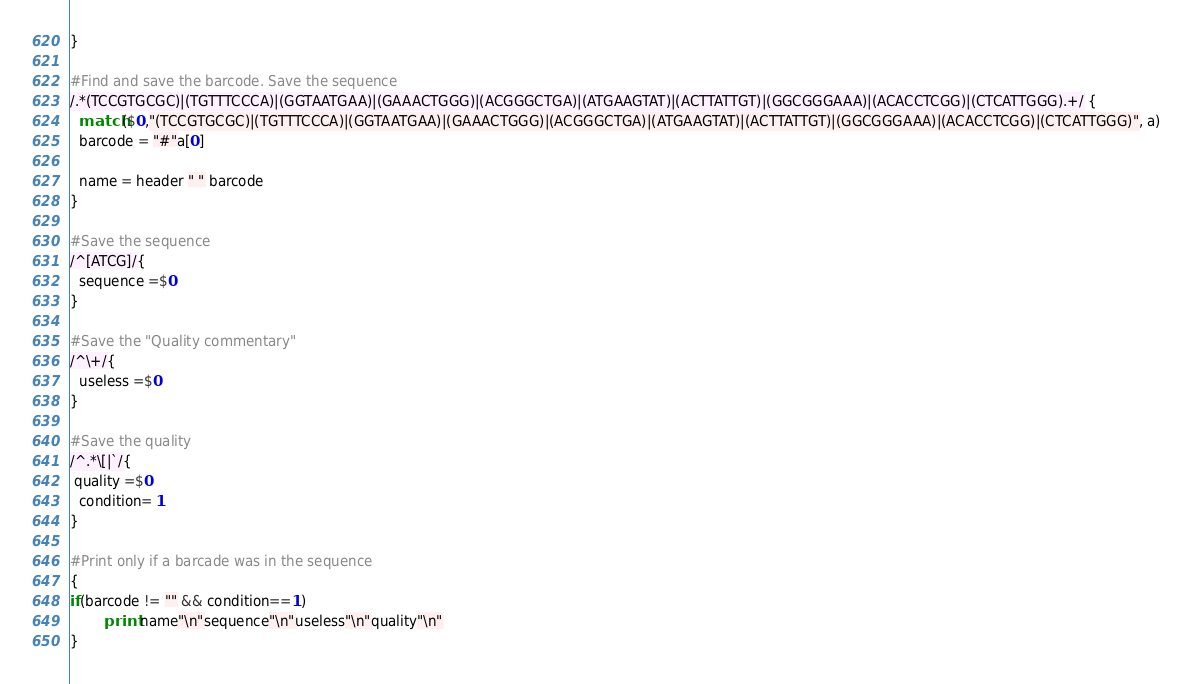<code> <loc_0><loc_0><loc_500><loc_500><_Awk_>}

#Find and save the barcode. Save the sequence
/.*(TCCGTGCGC)|(TGTTTCCCA)|(GGTAATGAA)|(GAAACTGGG)|(ACGGGCTGA)|(ATGAAGTAT)|(ACTTATTGT)|(GGCGGGAAA)|(ACACCTCGG)|(CTCATTGGG).+/ {
  match($0,"(TCCGTGCGC)|(TGTTTCCCA)|(GGTAATGAA)|(GAAACTGGG)|(ACGGGCTGA)|(ATGAAGTAT)|(ACTTATTGT)|(GGCGGGAAA)|(ACACCTCGG)|(CTCATTGGG)", a)
  barcode = "#"a[0]

  name = header " " barcode
}

#Save the sequence
/^[ATCG]/{
  sequence =$0
}

#Save the "Quality commentary"
/^\+/{
  useless =$0
}

#Save the quality
/^.*\[|`/{
 quality =$0
  condition= 1
}

#Print only if a barcade was in the sequence
{
if(barcode != "" && condition==1)
        print name"\n"sequence"\n"useless"\n"quality"\n"
}
</code> 